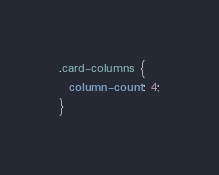<code> <loc_0><loc_0><loc_500><loc_500><_CSS_>.card-columns {
  column-count: 4;
}
</code> 